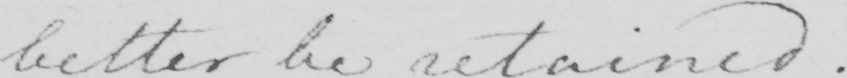What does this handwritten line say? better be retained .  _ 